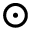<formula> <loc_0><loc_0><loc_500><loc_500>\odot</formula> 